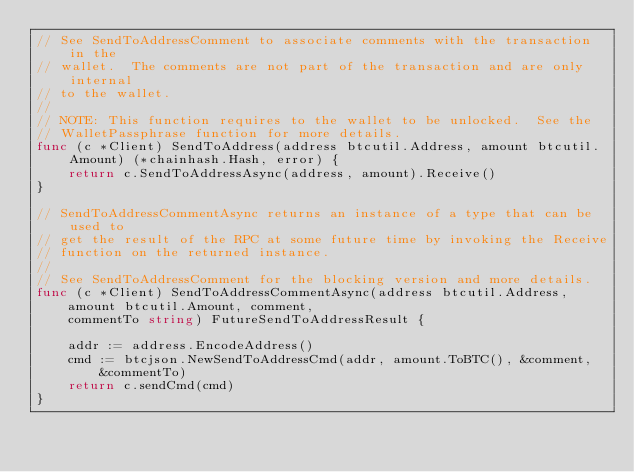<code> <loc_0><loc_0><loc_500><loc_500><_Go_>// See SendToAddressComment to associate comments with the transaction in the
// wallet.  The comments are not part of the transaction and are only internal
// to the wallet.
//
// NOTE: This function requires to the wallet to be unlocked.  See the
// WalletPassphrase function for more details.
func (c *Client) SendToAddress(address btcutil.Address, amount btcutil.Amount) (*chainhash.Hash, error) {
	return c.SendToAddressAsync(address, amount).Receive()
}

// SendToAddressCommentAsync returns an instance of a type that can be used to
// get the result of the RPC at some future time by invoking the Receive
// function on the returned instance.
//
// See SendToAddressComment for the blocking version and more details.
func (c *Client) SendToAddressCommentAsync(address btcutil.Address,
	amount btcutil.Amount, comment,
	commentTo string) FutureSendToAddressResult {

	addr := address.EncodeAddress()
	cmd := btcjson.NewSendToAddressCmd(addr, amount.ToBTC(), &comment,
		&commentTo)
	return c.sendCmd(cmd)
}
</code> 